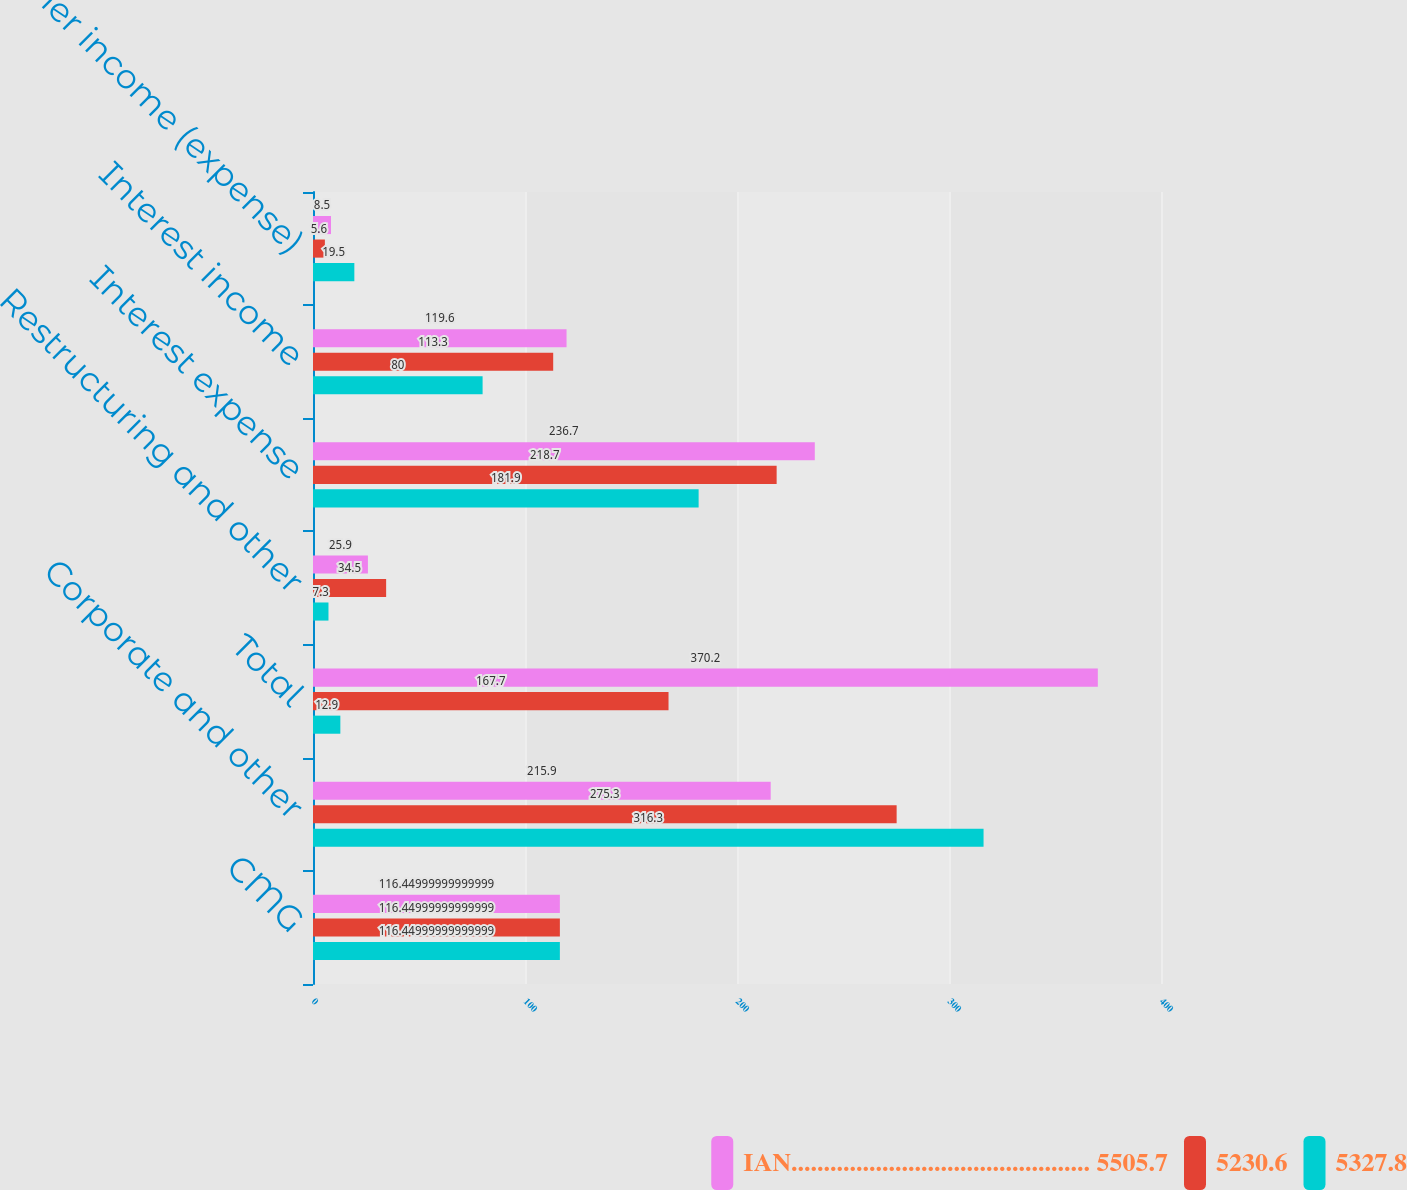Convert chart to OTSL. <chart><loc_0><loc_0><loc_500><loc_500><stacked_bar_chart><ecel><fcel>CMG<fcel>Corporate and other<fcel>Total<fcel>Restructuring and other<fcel>Interest expense<fcel>Interest income<fcel>Other income (expense)<nl><fcel>IAN.............................................. 5505.7<fcel>116.45<fcel>215.9<fcel>370.2<fcel>25.9<fcel>236.7<fcel>119.6<fcel>8.5<nl><fcel>5230.6<fcel>116.45<fcel>275.3<fcel>167.7<fcel>34.5<fcel>218.7<fcel>113.3<fcel>5.6<nl><fcel>5327.8<fcel>116.45<fcel>316.3<fcel>12.9<fcel>7.3<fcel>181.9<fcel>80<fcel>19.5<nl></chart> 